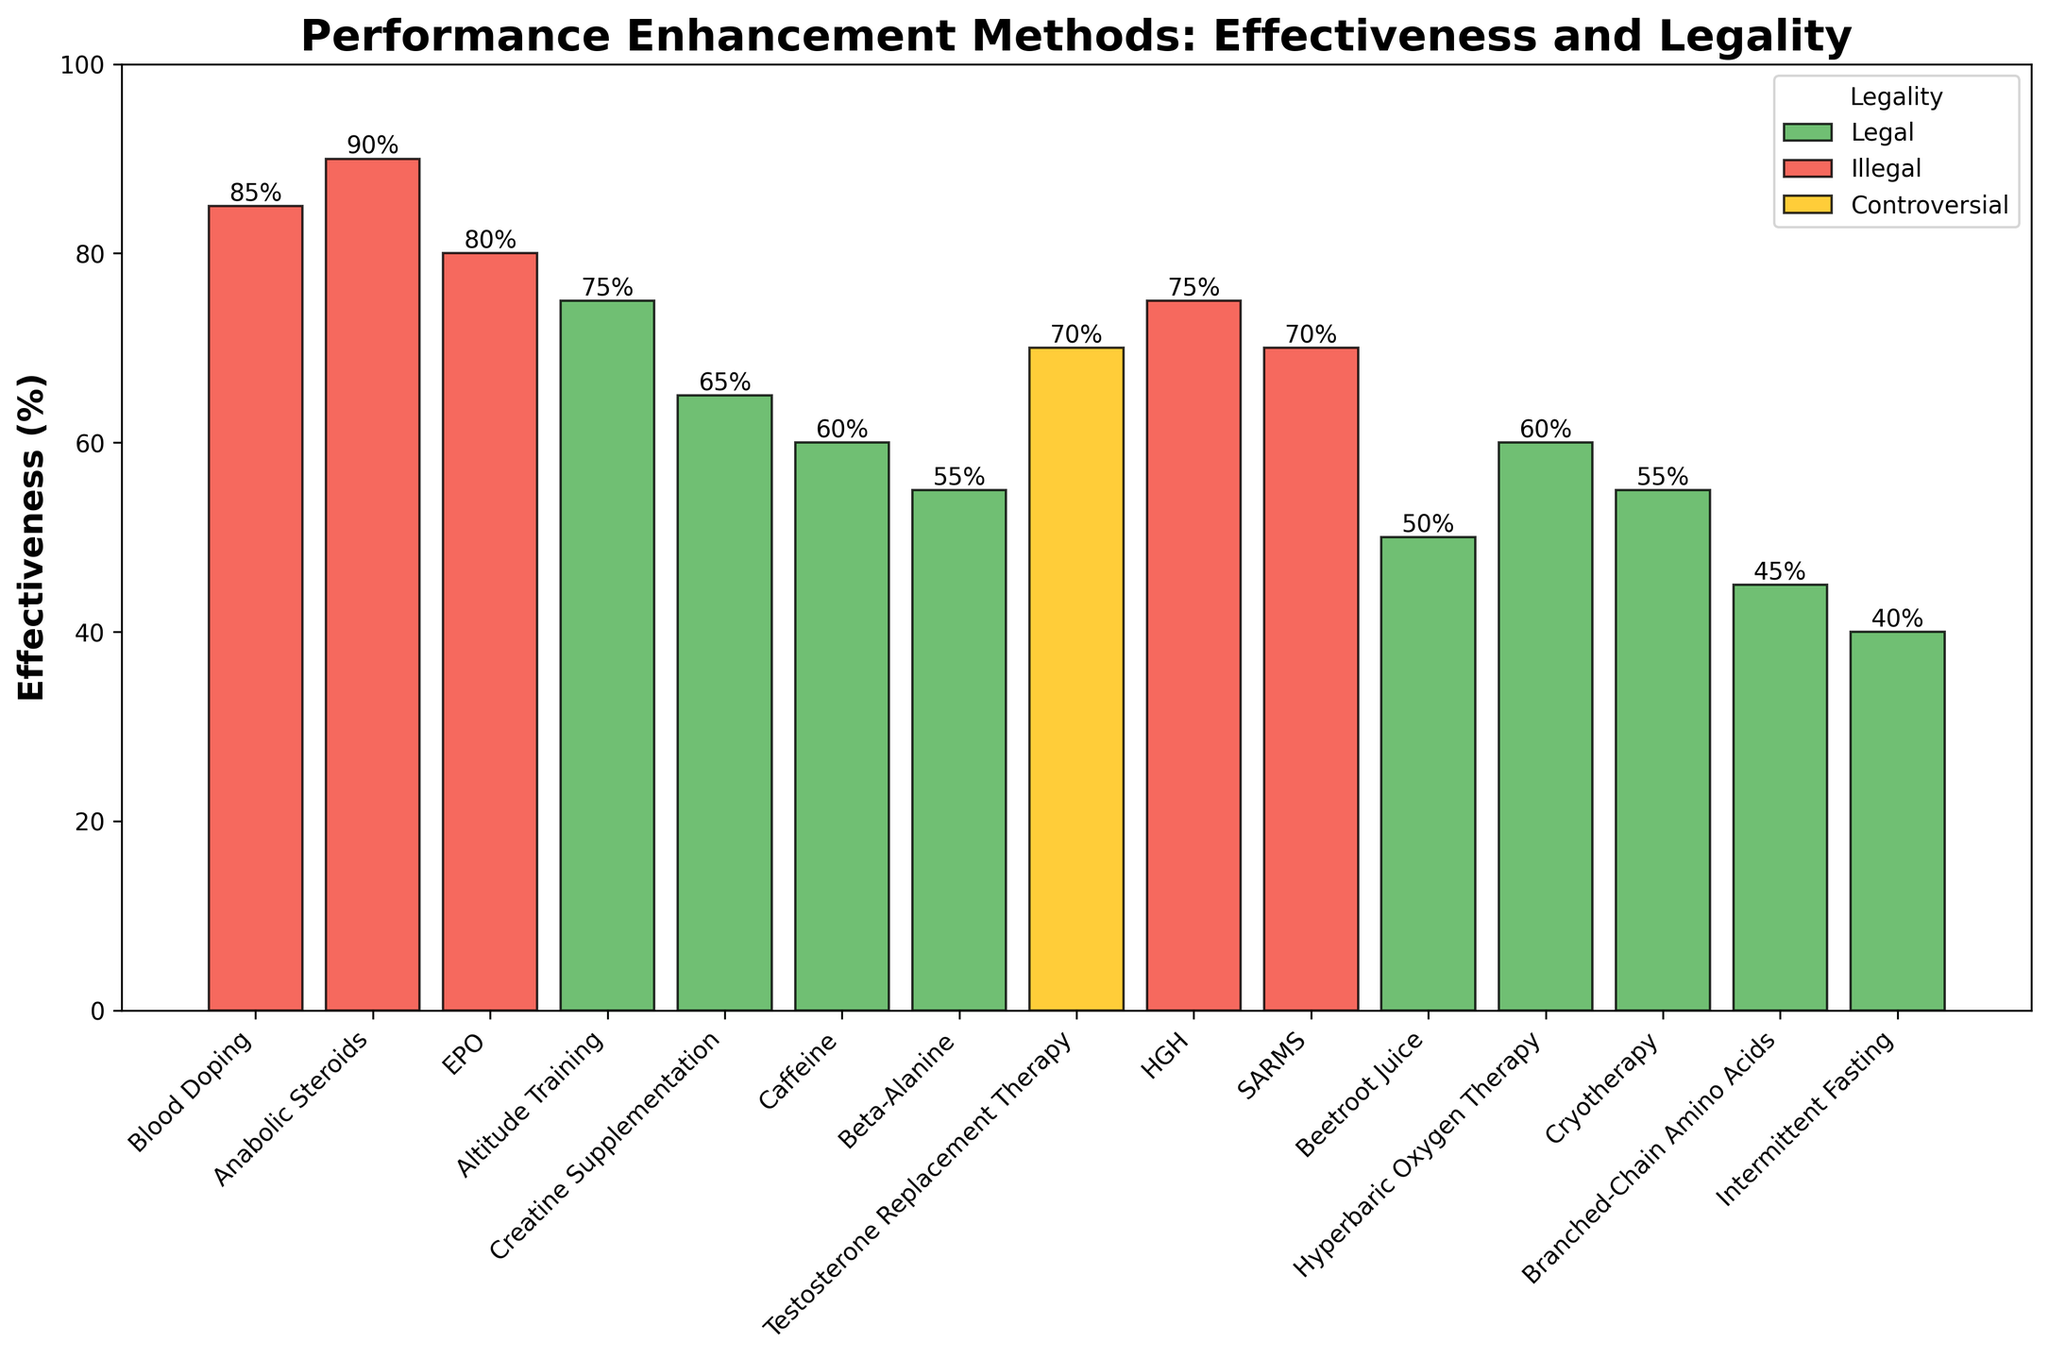Which method has the highest effectiveness? Look at the height of the bars and identify the one that reaches the highest percentage. Anabolic Steroids have the highest bar at 90%.
Answer: Anabolic Steroids What is the difference in effectiveness between Blood Doping and Creatine Supplementation? Find the effectiveness values of Blood Doping (85) and Creatine Supplementation (65), then subtract the latter from the former: 85 - 65 = 20
Answer: 20 Which legal method has the highest effectiveness? Among the bars colored green (indicating legal methods), identify the one with the highest value, which is Altitude Training at 75%.
Answer: Altitude Training How many methods have an effectiveness of 70% or higher? Count the bars whose heights represent a value of 70% or greater. There are Blood Doping (85%), Anabolic Steroids (90%), EPO (80%), Altitude Training (75%), HGH (75%), SARMS (70%), and Testosterone Replacement Therapy (70%).
Answer: 7 What is the average effectiveness of all legal methods? Sum the effectiveness of all legal methods (Altitude Training: 75, Creatine Supplementation: 65, Caffeine: 60, Beta-Alanine: 55, Beetroot Juice: 50, Hyperbaric Oxygen Therapy: 60, Cryotherapy: 55, Branched-Chain Amino Acids: 45, Intermittent Fasting: 40) and divide it by the number of these methods:
(75 + 65 + 60 + 55 + 50 + 60 + 55 + 45 + 40) / 9 = 56.11
Answer: 56.11 Which is more effective, Hyperbaric Oxygen Therapy or Cryotherapy? Compare the heights of the bars for Hyperbaric Oxygen Therapy and Cryotherapy. Hyperbaric Oxygen Therapy (60) is slightly higher than Cryotherapy (55).
Answer: Hyperbaric Oxygen Therapy Are there any methods with effectiveness exactly in the middle of the effectiveness range (i.e., around 50%)? Look for bars with heights around 50%, which represents the midpoint of the 0-100% effectiveness range. Beetroot Juice has an effectiveness of 50%.
Answer: Beetroot Juice What is the total effectiveness of controversial methods? Sum the effectiveness values of controversial methods, which include only Testosterone Replacement Therapy at 70%.
Answer: 70 